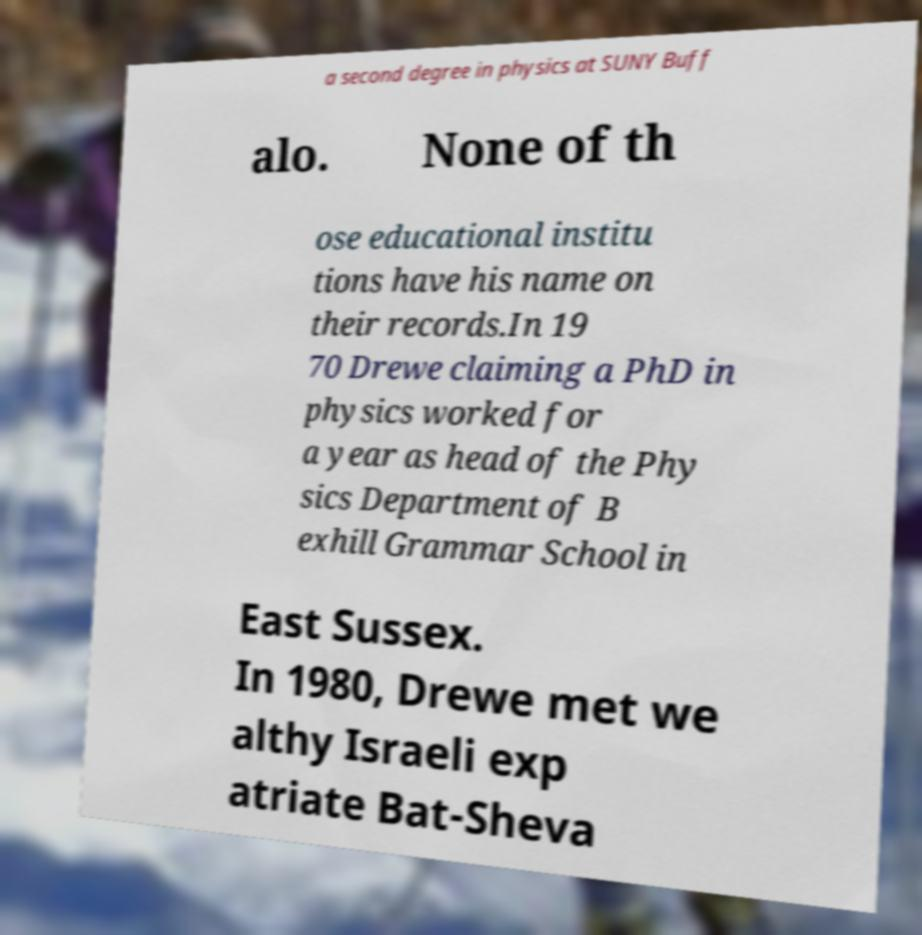For documentation purposes, I need the text within this image transcribed. Could you provide that? a second degree in physics at SUNY Buff alo. None of th ose educational institu tions have his name on their records.In 19 70 Drewe claiming a PhD in physics worked for a year as head of the Phy sics Department of B exhill Grammar School in East Sussex. In 1980, Drewe met we althy Israeli exp atriate Bat-Sheva 